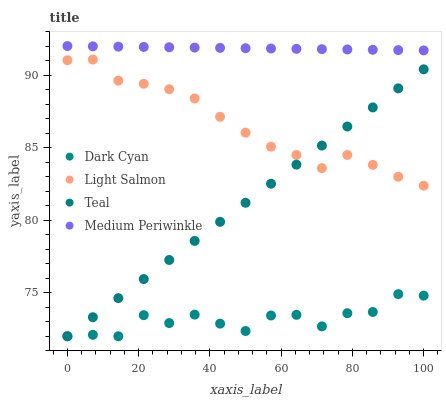Does Dark Cyan have the minimum area under the curve?
Answer yes or no. Yes. Does Medium Periwinkle have the maximum area under the curve?
Answer yes or no. Yes. Does Light Salmon have the minimum area under the curve?
Answer yes or no. No. Does Light Salmon have the maximum area under the curve?
Answer yes or no. No. Is Medium Periwinkle the smoothest?
Answer yes or no. Yes. Is Dark Cyan the roughest?
Answer yes or no. Yes. Is Light Salmon the smoothest?
Answer yes or no. No. Is Light Salmon the roughest?
Answer yes or no. No. Does Dark Cyan have the lowest value?
Answer yes or no. Yes. Does Light Salmon have the lowest value?
Answer yes or no. No. Does Medium Periwinkle have the highest value?
Answer yes or no. Yes. Does Light Salmon have the highest value?
Answer yes or no. No. Is Teal less than Medium Periwinkle?
Answer yes or no. Yes. Is Light Salmon greater than Dark Cyan?
Answer yes or no. Yes. Does Teal intersect Dark Cyan?
Answer yes or no. Yes. Is Teal less than Dark Cyan?
Answer yes or no. No. Is Teal greater than Dark Cyan?
Answer yes or no. No. Does Teal intersect Medium Periwinkle?
Answer yes or no. No. 